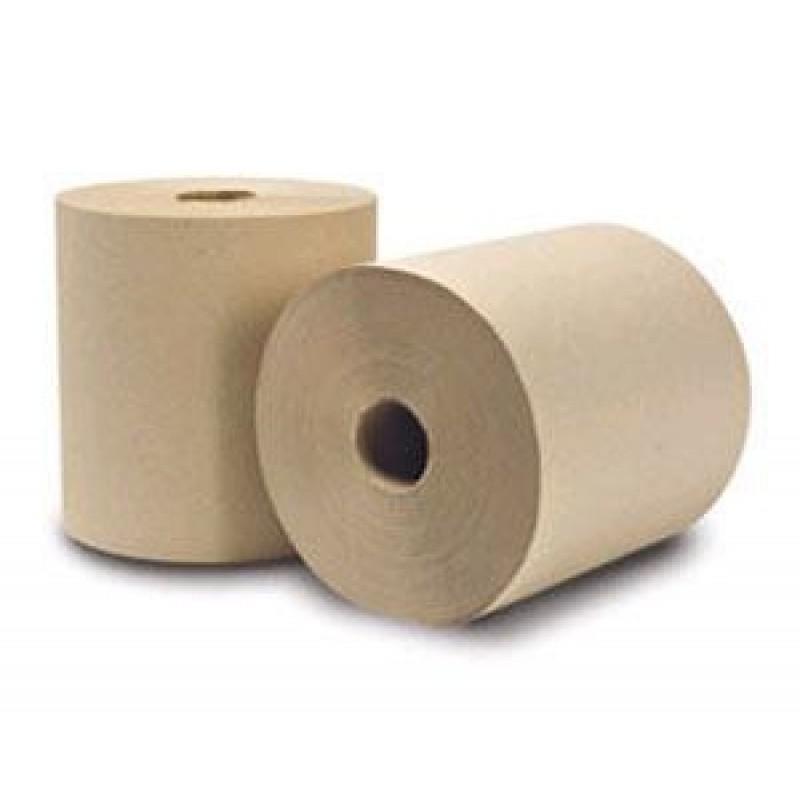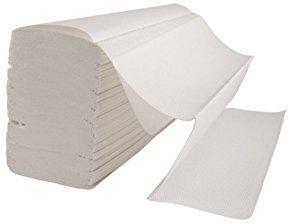The first image is the image on the left, the second image is the image on the right. Evaluate the accuracy of this statement regarding the images: "There is at least one roll of brown paper in the image on the left.". Is it true? Answer yes or no. Yes. The first image is the image on the left, the second image is the image on the right. Analyze the images presented: Is the assertion "Both paper rolls and paper towel stacks are shown." valid? Answer yes or no. Yes. 